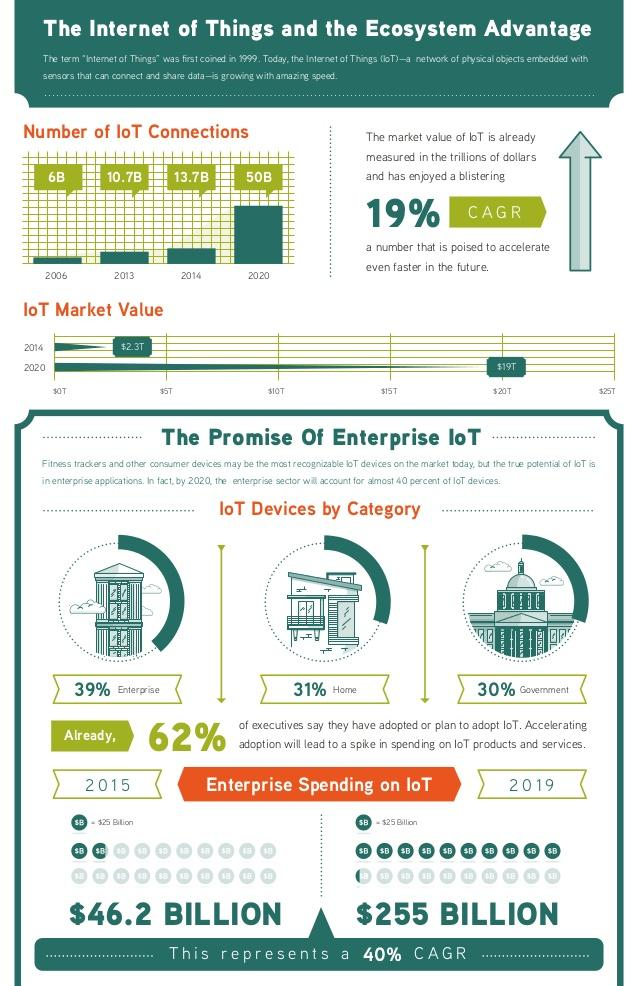Outline some significant characteristics in this image. The government sector accounts for nearly 30% of the IoT devices. In 2013, the number of IoT connections reached 10.7 billion. According to recent estimates, the global IoT market was valued at approximately $19 trillion in 2020. In 2014, the market value of IoT was estimated to be $2.3 trillion. In 2015, the enterprise spent a significant amount of $46.2 BILLION on IoT. 